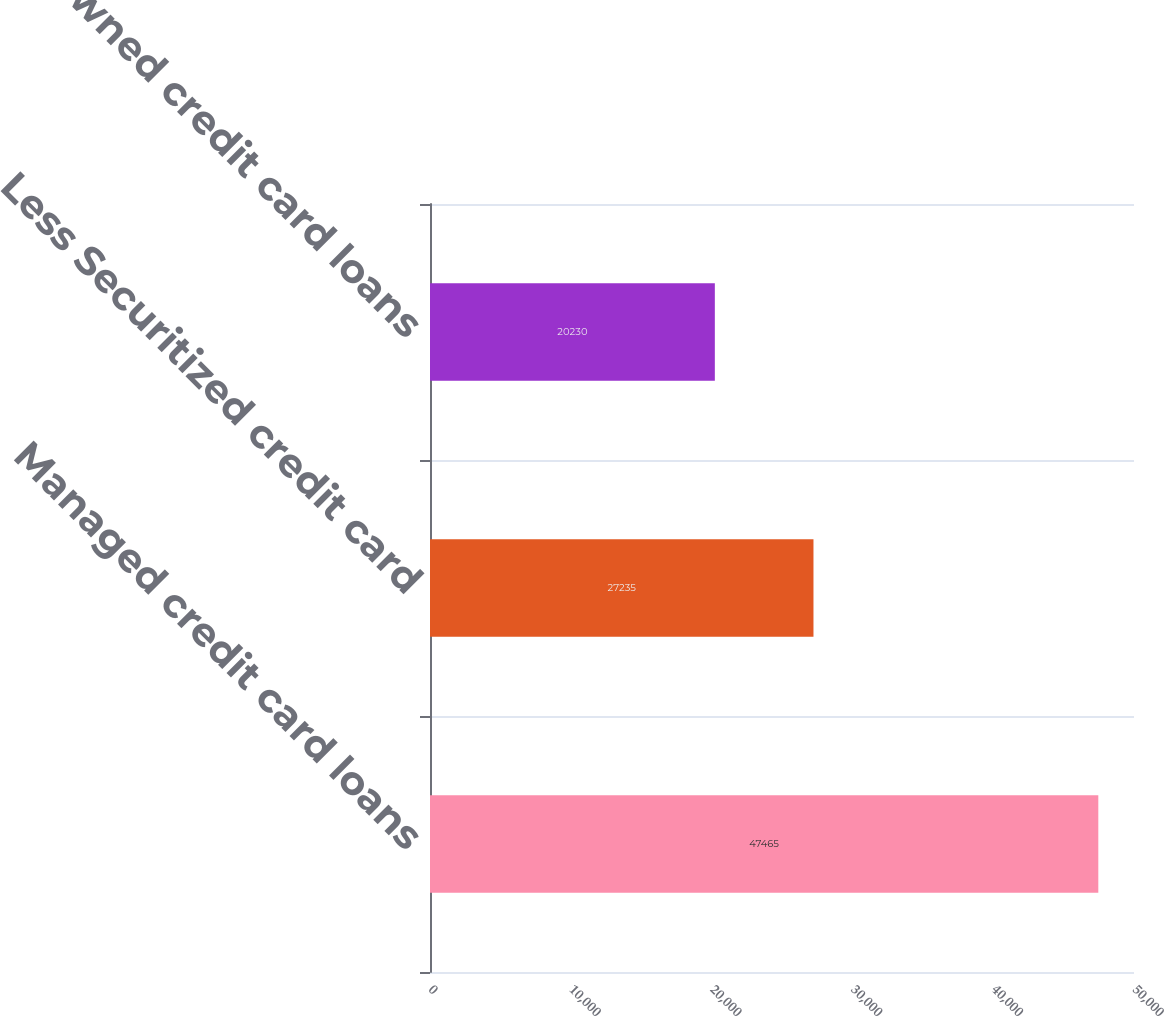Convert chart to OTSL. <chart><loc_0><loc_0><loc_500><loc_500><bar_chart><fcel>Managed credit card loans<fcel>Less Securitized credit card<fcel>Owned credit card loans<nl><fcel>47465<fcel>27235<fcel>20230<nl></chart> 